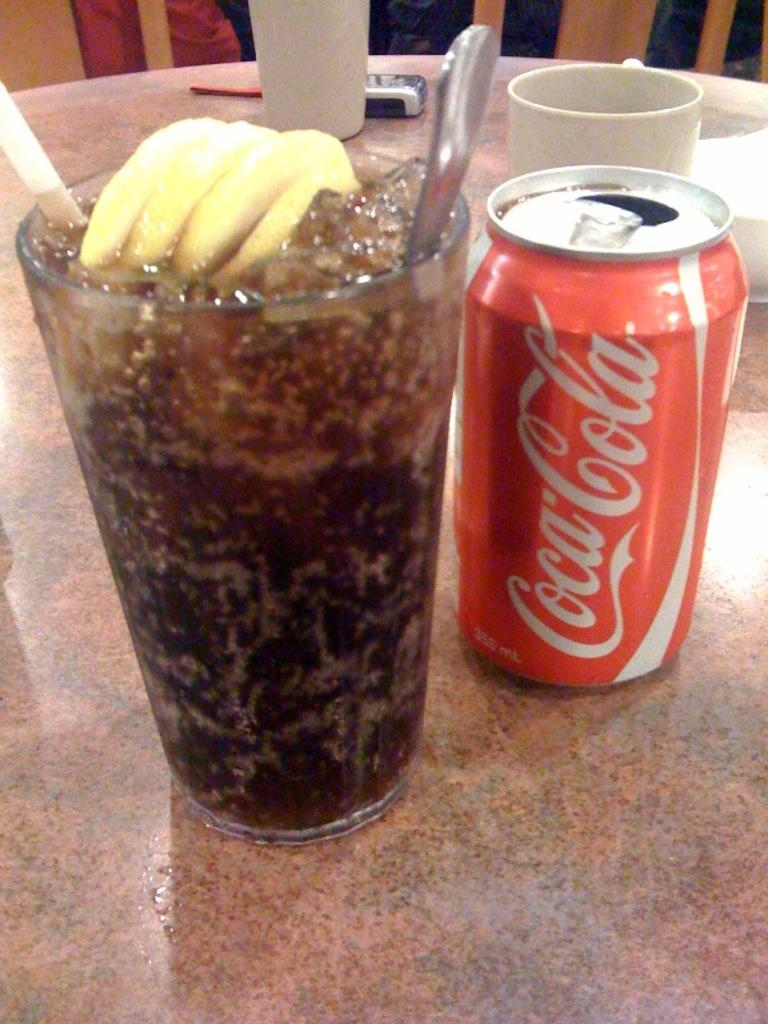What piece of furniture is present in the image? There is a table in the image. What is placed on the table? There is a glass, a mobile phone, a cup, and a tin on the table. Can you describe the objects on the table? The objects on the table include a glass, a mobile phone, a cup, and a tin. Is there a stream of water flowing across the table in the image? No, there is no stream of water present in the image. 